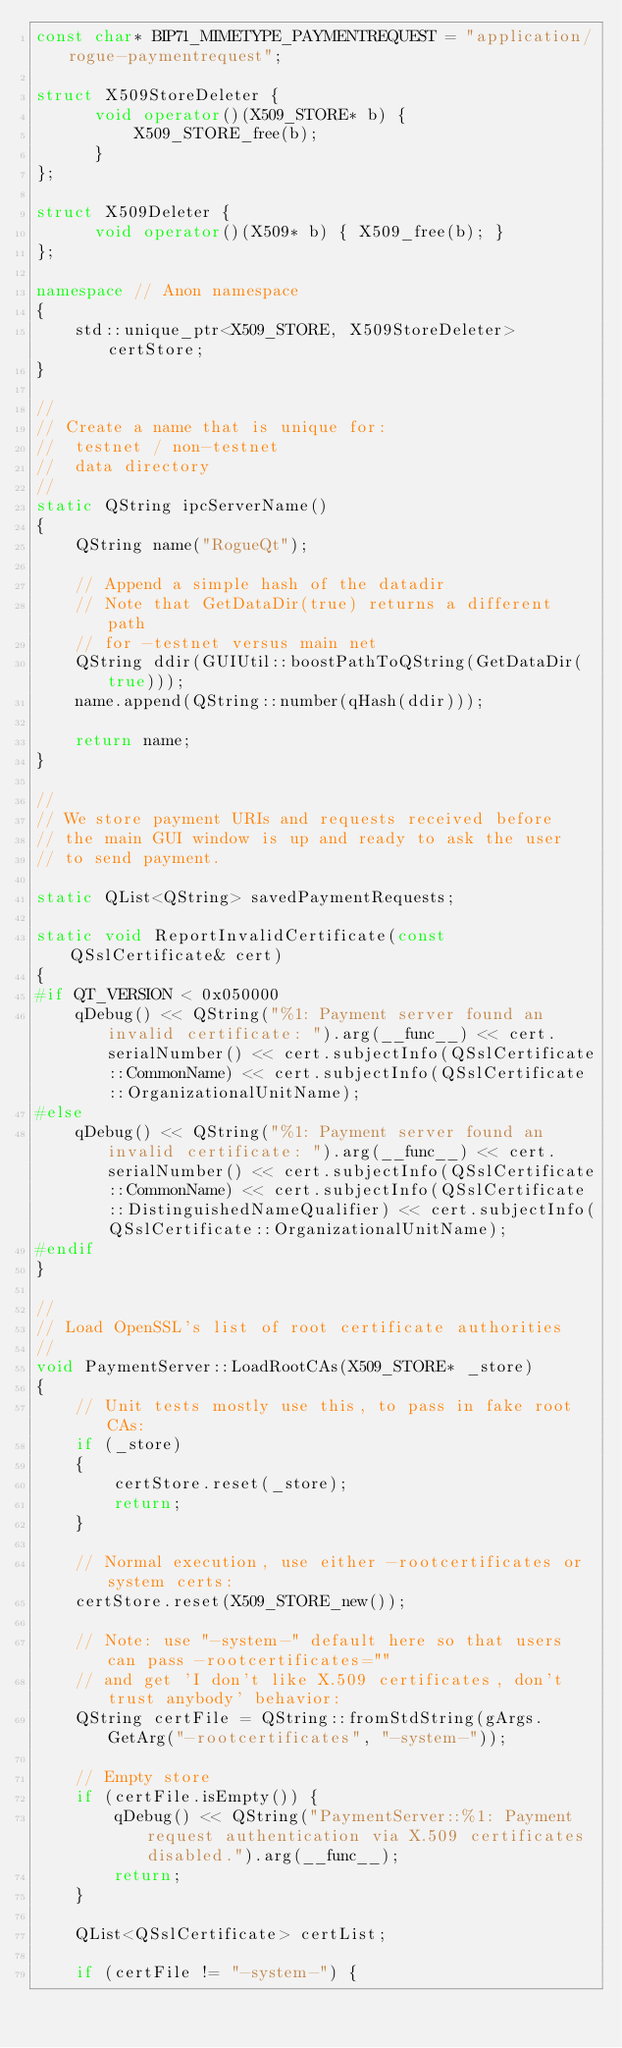Convert code to text. <code><loc_0><loc_0><loc_500><loc_500><_C++_>const char* BIP71_MIMETYPE_PAYMENTREQUEST = "application/rogue-paymentrequest";

struct X509StoreDeleter {
      void operator()(X509_STORE* b) {
          X509_STORE_free(b);
      }
};

struct X509Deleter {
      void operator()(X509* b) { X509_free(b); }
};

namespace // Anon namespace
{
    std::unique_ptr<X509_STORE, X509StoreDeleter> certStore;
}

//
// Create a name that is unique for:
//  testnet / non-testnet
//  data directory
//
static QString ipcServerName()
{
    QString name("RogueQt");

    // Append a simple hash of the datadir
    // Note that GetDataDir(true) returns a different path
    // for -testnet versus main net
    QString ddir(GUIUtil::boostPathToQString(GetDataDir(true)));
    name.append(QString::number(qHash(ddir)));

    return name;
}

//
// We store payment URIs and requests received before
// the main GUI window is up and ready to ask the user
// to send payment.

static QList<QString> savedPaymentRequests;

static void ReportInvalidCertificate(const QSslCertificate& cert)
{
#if QT_VERSION < 0x050000
    qDebug() << QString("%1: Payment server found an invalid certificate: ").arg(__func__) << cert.serialNumber() << cert.subjectInfo(QSslCertificate::CommonName) << cert.subjectInfo(QSslCertificate::OrganizationalUnitName);
#else
    qDebug() << QString("%1: Payment server found an invalid certificate: ").arg(__func__) << cert.serialNumber() << cert.subjectInfo(QSslCertificate::CommonName) << cert.subjectInfo(QSslCertificate::DistinguishedNameQualifier) << cert.subjectInfo(QSslCertificate::OrganizationalUnitName);
#endif
}

//
// Load OpenSSL's list of root certificate authorities
//
void PaymentServer::LoadRootCAs(X509_STORE* _store)
{
    // Unit tests mostly use this, to pass in fake root CAs:
    if (_store)
    {
        certStore.reset(_store);
        return;
    }

    // Normal execution, use either -rootcertificates or system certs:
    certStore.reset(X509_STORE_new());

    // Note: use "-system-" default here so that users can pass -rootcertificates=""
    // and get 'I don't like X.509 certificates, don't trust anybody' behavior:
    QString certFile = QString::fromStdString(gArgs.GetArg("-rootcertificates", "-system-"));

    // Empty store
    if (certFile.isEmpty()) {
        qDebug() << QString("PaymentServer::%1: Payment request authentication via X.509 certificates disabled.").arg(__func__);
        return;
    }

    QList<QSslCertificate> certList;

    if (certFile != "-system-") {</code> 